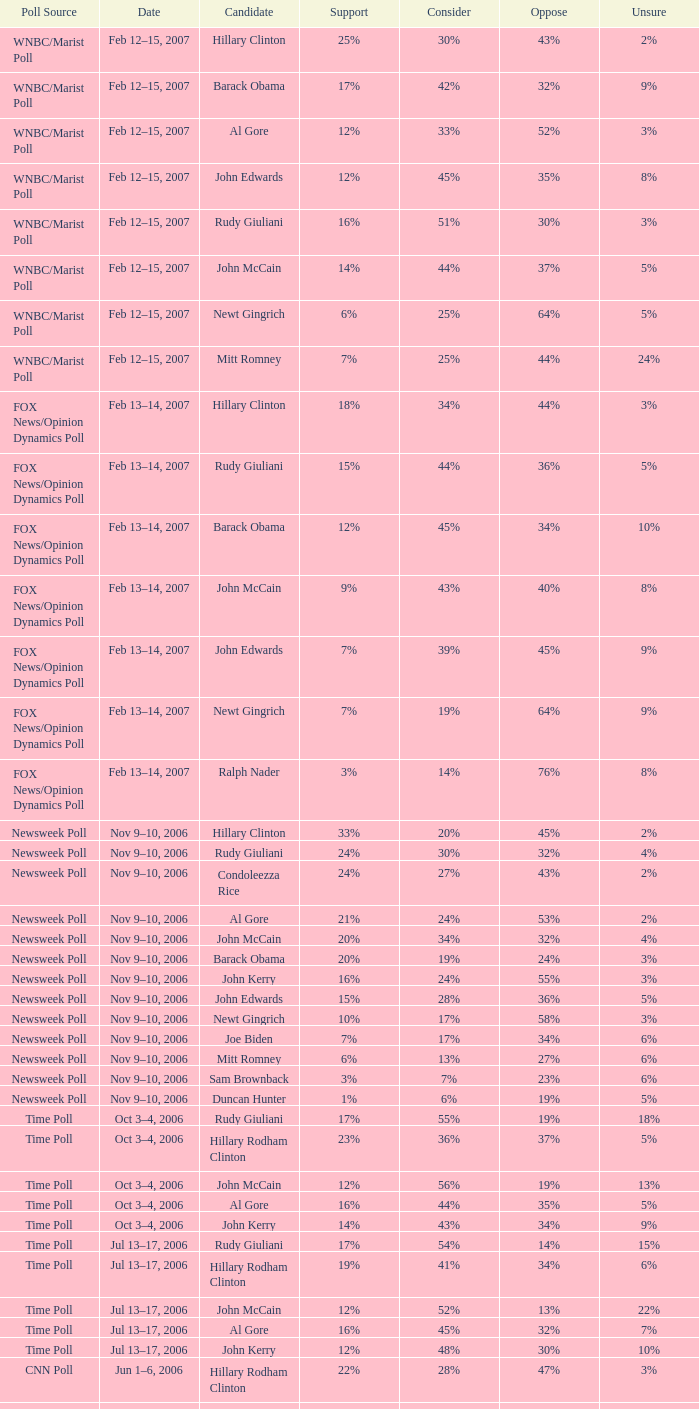Could you help me parse every detail presented in this table? {'header': ['Poll Source', 'Date', 'Candidate', 'Support', 'Consider', 'Oppose', 'Unsure'], 'rows': [['WNBC/Marist Poll', 'Feb 12–15, 2007', 'Hillary Clinton', '25%', '30%', '43%', '2%'], ['WNBC/Marist Poll', 'Feb 12–15, 2007', 'Barack Obama', '17%', '42%', '32%', '9%'], ['WNBC/Marist Poll', 'Feb 12–15, 2007', 'Al Gore', '12%', '33%', '52%', '3%'], ['WNBC/Marist Poll', 'Feb 12–15, 2007', 'John Edwards', '12%', '45%', '35%', '8%'], ['WNBC/Marist Poll', 'Feb 12–15, 2007', 'Rudy Giuliani', '16%', '51%', '30%', '3%'], ['WNBC/Marist Poll', 'Feb 12–15, 2007', 'John McCain', '14%', '44%', '37%', '5%'], ['WNBC/Marist Poll', 'Feb 12–15, 2007', 'Newt Gingrich', '6%', '25%', '64%', '5%'], ['WNBC/Marist Poll', 'Feb 12–15, 2007', 'Mitt Romney', '7%', '25%', '44%', '24%'], ['FOX News/Opinion Dynamics Poll', 'Feb 13–14, 2007', 'Hillary Clinton', '18%', '34%', '44%', '3%'], ['FOX News/Opinion Dynamics Poll', 'Feb 13–14, 2007', 'Rudy Giuliani', '15%', '44%', '36%', '5%'], ['FOX News/Opinion Dynamics Poll', 'Feb 13–14, 2007', 'Barack Obama', '12%', '45%', '34%', '10%'], ['FOX News/Opinion Dynamics Poll', 'Feb 13–14, 2007', 'John McCain', '9%', '43%', '40%', '8%'], ['FOX News/Opinion Dynamics Poll', 'Feb 13–14, 2007', 'John Edwards', '7%', '39%', '45%', '9%'], ['FOX News/Opinion Dynamics Poll', 'Feb 13–14, 2007', 'Newt Gingrich', '7%', '19%', '64%', '9%'], ['FOX News/Opinion Dynamics Poll', 'Feb 13–14, 2007', 'Ralph Nader', '3%', '14%', '76%', '8%'], ['Newsweek Poll', 'Nov 9–10, 2006', 'Hillary Clinton', '33%', '20%', '45%', '2%'], ['Newsweek Poll', 'Nov 9–10, 2006', 'Rudy Giuliani', '24%', '30%', '32%', '4%'], ['Newsweek Poll', 'Nov 9–10, 2006', 'Condoleezza Rice', '24%', '27%', '43%', '2%'], ['Newsweek Poll', 'Nov 9–10, 2006', 'Al Gore', '21%', '24%', '53%', '2%'], ['Newsweek Poll', 'Nov 9–10, 2006', 'John McCain', '20%', '34%', '32%', '4%'], ['Newsweek Poll', 'Nov 9–10, 2006', 'Barack Obama', '20%', '19%', '24%', '3%'], ['Newsweek Poll', 'Nov 9–10, 2006', 'John Kerry', '16%', '24%', '55%', '3%'], ['Newsweek Poll', 'Nov 9–10, 2006', 'John Edwards', '15%', '28%', '36%', '5%'], ['Newsweek Poll', 'Nov 9–10, 2006', 'Newt Gingrich', '10%', '17%', '58%', '3%'], ['Newsweek Poll', 'Nov 9–10, 2006', 'Joe Biden', '7%', '17%', '34%', '6%'], ['Newsweek Poll', 'Nov 9–10, 2006', 'Mitt Romney', '6%', '13%', '27%', '6%'], ['Newsweek Poll', 'Nov 9–10, 2006', 'Sam Brownback', '3%', '7%', '23%', '6%'], ['Newsweek Poll', 'Nov 9–10, 2006', 'Duncan Hunter', '1%', '6%', '19%', '5%'], ['Time Poll', 'Oct 3–4, 2006', 'Rudy Giuliani', '17%', '55%', '19%', '18%'], ['Time Poll', 'Oct 3–4, 2006', 'Hillary Rodham Clinton', '23%', '36%', '37%', '5%'], ['Time Poll', 'Oct 3–4, 2006', 'John McCain', '12%', '56%', '19%', '13%'], ['Time Poll', 'Oct 3–4, 2006', 'Al Gore', '16%', '44%', '35%', '5%'], ['Time Poll', 'Oct 3–4, 2006', 'John Kerry', '14%', '43%', '34%', '9%'], ['Time Poll', 'Jul 13–17, 2006', 'Rudy Giuliani', '17%', '54%', '14%', '15%'], ['Time Poll', 'Jul 13–17, 2006', 'Hillary Rodham Clinton', '19%', '41%', '34%', '6%'], ['Time Poll', 'Jul 13–17, 2006', 'John McCain', '12%', '52%', '13%', '22%'], ['Time Poll', 'Jul 13–17, 2006', 'Al Gore', '16%', '45%', '32%', '7%'], ['Time Poll', 'Jul 13–17, 2006', 'John Kerry', '12%', '48%', '30%', '10%'], ['CNN Poll', 'Jun 1–6, 2006', 'Hillary Rodham Clinton', '22%', '28%', '47%', '3%'], ['CNN Poll', 'Jun 1–6, 2006', 'Al Gore', '17%', '32%', '48%', '3%'], ['CNN Poll', 'Jun 1–6, 2006', 'John Kerry', '14%', '35%', '47%', '4%'], ['CNN Poll', 'Jun 1–6, 2006', 'Rudolph Giuliani', '19%', '45%', '30%', '6%'], ['CNN Poll', 'Jun 1–6, 2006', 'John McCain', '12%', '48%', '34%', '6%'], ['CNN Poll', 'Jun 1–6, 2006', 'Jeb Bush', '9%', '26%', '63%', '2%'], ['ABC News/Washington Post Poll', 'May 11–15, 2006', 'Hillary Clinton', '19%', '38%', '42%', '1%'], ['ABC News/Washington Post Poll', 'May 11–15, 2006', 'John McCain', '9%', '57%', '28%', '6%'], ['FOX News/Opinion Dynamics Poll', 'Feb 7–8, 2006', 'Hillary Clinton', '35%', '19%', '44%', '2%'], ['FOX News/Opinion Dynamics Poll', 'Feb 7–8, 2006', 'Rudy Giuliani', '33%', '38%', '24%', '6%'], ['FOX News/Opinion Dynamics Poll', 'Feb 7–8, 2006', 'John McCain', '30%', '40%', '22%', '7%'], ['FOX News/Opinion Dynamics Poll', 'Feb 7–8, 2006', 'John Kerry', '29%', '23%', '45%', '3%'], ['FOX News/Opinion Dynamics Poll', 'Feb 7–8, 2006', 'Condoleezza Rice', '14%', '38%', '46%', '3%'], ['CNN/USA Today/Gallup Poll', 'Jan 20–22, 2006', 'Hillary Rodham Clinton', '16%', '32%', '51%', '1%'], ['Diageo/Hotline Poll', 'Nov 11–15, 2005', 'John McCain', '23%', '46%', '15%', '15%'], ['CNN/USA Today/Gallup Poll', 'May 20–22, 2005', 'Hillary Rodham Clinton', '28%', '31%', '40%', '1%'], ['CNN/USA Today/Gallup Poll', 'Jun 9–10, 2003', 'Hillary Rodham Clinton', '20%', '33%', '45%', '2%']]} What percentage of people were opposed to the candidate based on the Time Poll poll that showed 6% of people were unsure? 34%. 